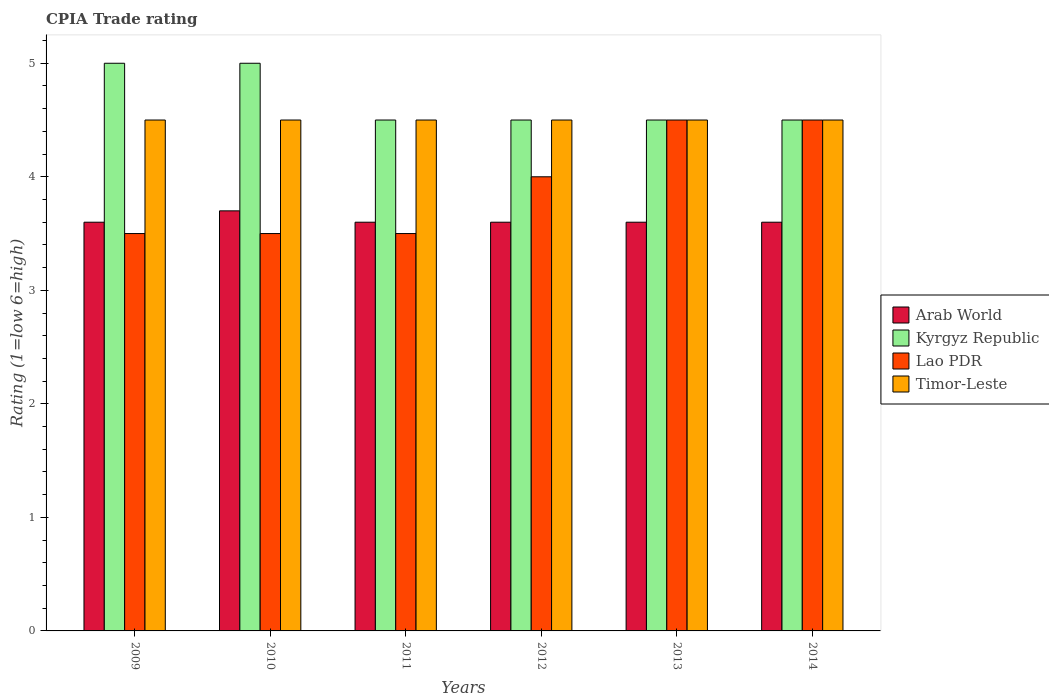How many groups of bars are there?
Ensure brevity in your answer.  6. How many bars are there on the 2nd tick from the right?
Your response must be concise. 4. What is the label of the 1st group of bars from the left?
Offer a very short reply. 2009. Across all years, what is the maximum CPIA rating in Timor-Leste?
Your response must be concise. 4.5. In which year was the CPIA rating in Kyrgyz Republic minimum?
Make the answer very short. 2011. What is the difference between the CPIA rating in Arab World in 2010 and the CPIA rating in Timor-Leste in 2013?
Your answer should be compact. -0.8. What is the average CPIA rating in Timor-Leste per year?
Make the answer very short. 4.5. In the year 2010, what is the difference between the CPIA rating in Arab World and CPIA rating in Timor-Leste?
Provide a succinct answer. -0.8. What is the ratio of the CPIA rating in Timor-Leste in 2010 to that in 2011?
Your response must be concise. 1. Is the CPIA rating in Timor-Leste in 2010 less than that in 2014?
Give a very brief answer. No. Is the difference between the CPIA rating in Arab World in 2009 and 2010 greater than the difference between the CPIA rating in Timor-Leste in 2009 and 2010?
Your response must be concise. No. What is the difference between the highest and the lowest CPIA rating in Lao PDR?
Your answer should be compact. 1. In how many years, is the CPIA rating in Arab World greater than the average CPIA rating in Arab World taken over all years?
Keep it short and to the point. 1. Is the sum of the CPIA rating in Kyrgyz Republic in 2011 and 2013 greater than the maximum CPIA rating in Lao PDR across all years?
Make the answer very short. Yes. What does the 3rd bar from the left in 2014 represents?
Make the answer very short. Lao PDR. What does the 2nd bar from the right in 2011 represents?
Give a very brief answer. Lao PDR. Is it the case that in every year, the sum of the CPIA rating in Timor-Leste and CPIA rating in Kyrgyz Republic is greater than the CPIA rating in Lao PDR?
Keep it short and to the point. Yes. Are all the bars in the graph horizontal?
Offer a terse response. No. How many years are there in the graph?
Provide a succinct answer. 6. What is the difference between two consecutive major ticks on the Y-axis?
Offer a very short reply. 1. Are the values on the major ticks of Y-axis written in scientific E-notation?
Offer a terse response. No. Does the graph contain any zero values?
Your answer should be very brief. No. How many legend labels are there?
Make the answer very short. 4. How are the legend labels stacked?
Ensure brevity in your answer.  Vertical. What is the title of the graph?
Offer a very short reply. CPIA Trade rating. What is the label or title of the X-axis?
Offer a very short reply. Years. What is the Rating (1=low 6=high) of Kyrgyz Republic in 2009?
Provide a short and direct response. 5. What is the Rating (1=low 6=high) of Arab World in 2010?
Your answer should be compact. 3.7. What is the Rating (1=low 6=high) in Timor-Leste in 2010?
Keep it short and to the point. 4.5. What is the Rating (1=low 6=high) in Arab World in 2011?
Make the answer very short. 3.6. What is the Rating (1=low 6=high) in Arab World in 2012?
Keep it short and to the point. 3.6. What is the Rating (1=low 6=high) of Lao PDR in 2012?
Your answer should be very brief. 4. What is the Rating (1=low 6=high) in Timor-Leste in 2012?
Offer a very short reply. 4.5. What is the Rating (1=low 6=high) of Kyrgyz Republic in 2013?
Keep it short and to the point. 4.5. What is the Rating (1=low 6=high) in Timor-Leste in 2013?
Provide a short and direct response. 4.5. What is the Rating (1=low 6=high) of Lao PDR in 2014?
Provide a short and direct response. 4.5. Across all years, what is the maximum Rating (1=low 6=high) of Lao PDR?
Keep it short and to the point. 4.5. Across all years, what is the maximum Rating (1=low 6=high) of Timor-Leste?
Give a very brief answer. 4.5. Across all years, what is the minimum Rating (1=low 6=high) in Arab World?
Your response must be concise. 3.6. Across all years, what is the minimum Rating (1=low 6=high) of Kyrgyz Republic?
Make the answer very short. 4.5. Across all years, what is the minimum Rating (1=low 6=high) in Lao PDR?
Offer a very short reply. 3.5. Across all years, what is the minimum Rating (1=low 6=high) in Timor-Leste?
Your answer should be compact. 4.5. What is the total Rating (1=low 6=high) of Arab World in the graph?
Make the answer very short. 21.7. What is the total Rating (1=low 6=high) of Kyrgyz Republic in the graph?
Your response must be concise. 28. What is the difference between the Rating (1=low 6=high) in Arab World in 2009 and that in 2010?
Give a very brief answer. -0.1. What is the difference between the Rating (1=low 6=high) of Kyrgyz Republic in 2009 and that in 2010?
Your answer should be very brief. 0. What is the difference between the Rating (1=low 6=high) of Timor-Leste in 2009 and that in 2010?
Make the answer very short. 0. What is the difference between the Rating (1=low 6=high) of Arab World in 2009 and that in 2011?
Make the answer very short. 0. What is the difference between the Rating (1=low 6=high) of Kyrgyz Republic in 2009 and that in 2011?
Offer a very short reply. 0.5. What is the difference between the Rating (1=low 6=high) of Timor-Leste in 2009 and that in 2011?
Provide a succinct answer. 0. What is the difference between the Rating (1=low 6=high) of Arab World in 2009 and that in 2012?
Make the answer very short. 0. What is the difference between the Rating (1=low 6=high) of Kyrgyz Republic in 2009 and that in 2014?
Provide a short and direct response. 0.5. What is the difference between the Rating (1=low 6=high) of Lao PDR in 2009 and that in 2014?
Keep it short and to the point. -1. What is the difference between the Rating (1=low 6=high) of Timor-Leste in 2009 and that in 2014?
Make the answer very short. 0. What is the difference between the Rating (1=low 6=high) of Arab World in 2010 and that in 2011?
Keep it short and to the point. 0.1. What is the difference between the Rating (1=low 6=high) in Timor-Leste in 2010 and that in 2011?
Ensure brevity in your answer.  0. What is the difference between the Rating (1=low 6=high) of Arab World in 2010 and that in 2012?
Ensure brevity in your answer.  0.1. What is the difference between the Rating (1=low 6=high) in Lao PDR in 2010 and that in 2012?
Offer a terse response. -0.5. What is the difference between the Rating (1=low 6=high) in Lao PDR in 2011 and that in 2012?
Provide a short and direct response. -0.5. What is the difference between the Rating (1=low 6=high) in Timor-Leste in 2011 and that in 2012?
Keep it short and to the point. 0. What is the difference between the Rating (1=low 6=high) in Arab World in 2011 and that in 2013?
Provide a short and direct response. 0. What is the difference between the Rating (1=low 6=high) in Lao PDR in 2011 and that in 2013?
Your answer should be very brief. -1. What is the difference between the Rating (1=low 6=high) in Timor-Leste in 2011 and that in 2013?
Provide a short and direct response. 0. What is the difference between the Rating (1=low 6=high) of Timor-Leste in 2011 and that in 2014?
Your response must be concise. 0. What is the difference between the Rating (1=low 6=high) in Arab World in 2012 and that in 2013?
Keep it short and to the point. 0. What is the difference between the Rating (1=low 6=high) in Kyrgyz Republic in 2012 and that in 2013?
Provide a short and direct response. 0. What is the difference between the Rating (1=low 6=high) in Timor-Leste in 2012 and that in 2013?
Your answer should be very brief. 0. What is the difference between the Rating (1=low 6=high) of Arab World in 2012 and that in 2014?
Offer a terse response. 0. What is the difference between the Rating (1=low 6=high) in Kyrgyz Republic in 2012 and that in 2014?
Provide a short and direct response. 0. What is the difference between the Rating (1=low 6=high) in Timor-Leste in 2012 and that in 2014?
Provide a short and direct response. 0. What is the difference between the Rating (1=low 6=high) in Arab World in 2013 and that in 2014?
Offer a terse response. 0. What is the difference between the Rating (1=low 6=high) of Timor-Leste in 2013 and that in 2014?
Provide a succinct answer. 0. What is the difference between the Rating (1=low 6=high) of Arab World in 2009 and the Rating (1=low 6=high) of Lao PDR in 2010?
Offer a very short reply. 0.1. What is the difference between the Rating (1=low 6=high) in Lao PDR in 2009 and the Rating (1=low 6=high) in Timor-Leste in 2010?
Make the answer very short. -1. What is the difference between the Rating (1=low 6=high) in Arab World in 2009 and the Rating (1=low 6=high) in Timor-Leste in 2011?
Provide a short and direct response. -0.9. What is the difference between the Rating (1=low 6=high) of Kyrgyz Republic in 2009 and the Rating (1=low 6=high) of Lao PDR in 2011?
Provide a short and direct response. 1.5. What is the difference between the Rating (1=low 6=high) in Lao PDR in 2009 and the Rating (1=low 6=high) in Timor-Leste in 2011?
Ensure brevity in your answer.  -1. What is the difference between the Rating (1=low 6=high) in Arab World in 2009 and the Rating (1=low 6=high) in Kyrgyz Republic in 2012?
Your response must be concise. -0.9. What is the difference between the Rating (1=low 6=high) of Kyrgyz Republic in 2009 and the Rating (1=low 6=high) of Lao PDR in 2012?
Make the answer very short. 1. What is the difference between the Rating (1=low 6=high) of Lao PDR in 2009 and the Rating (1=low 6=high) of Timor-Leste in 2012?
Your answer should be very brief. -1. What is the difference between the Rating (1=low 6=high) in Arab World in 2009 and the Rating (1=low 6=high) in Kyrgyz Republic in 2013?
Offer a terse response. -0.9. What is the difference between the Rating (1=low 6=high) in Arab World in 2009 and the Rating (1=low 6=high) in Lao PDR in 2013?
Keep it short and to the point. -0.9. What is the difference between the Rating (1=low 6=high) in Kyrgyz Republic in 2009 and the Rating (1=low 6=high) in Lao PDR in 2013?
Your answer should be compact. 0.5. What is the difference between the Rating (1=low 6=high) in Lao PDR in 2009 and the Rating (1=low 6=high) in Timor-Leste in 2013?
Keep it short and to the point. -1. What is the difference between the Rating (1=low 6=high) of Arab World in 2010 and the Rating (1=low 6=high) of Timor-Leste in 2011?
Provide a succinct answer. -0.8. What is the difference between the Rating (1=low 6=high) of Kyrgyz Republic in 2010 and the Rating (1=low 6=high) of Lao PDR in 2011?
Your response must be concise. 1.5. What is the difference between the Rating (1=low 6=high) in Arab World in 2010 and the Rating (1=low 6=high) in Timor-Leste in 2012?
Keep it short and to the point. -0.8. What is the difference between the Rating (1=low 6=high) in Kyrgyz Republic in 2010 and the Rating (1=low 6=high) in Timor-Leste in 2012?
Give a very brief answer. 0.5. What is the difference between the Rating (1=low 6=high) of Arab World in 2010 and the Rating (1=low 6=high) of Lao PDR in 2013?
Make the answer very short. -0.8. What is the difference between the Rating (1=low 6=high) of Kyrgyz Republic in 2010 and the Rating (1=low 6=high) of Lao PDR in 2013?
Your answer should be compact. 0.5. What is the difference between the Rating (1=low 6=high) in Arab World in 2010 and the Rating (1=low 6=high) in Kyrgyz Republic in 2014?
Your answer should be compact. -0.8. What is the difference between the Rating (1=low 6=high) in Arab World in 2010 and the Rating (1=low 6=high) in Lao PDR in 2014?
Your answer should be very brief. -0.8. What is the difference between the Rating (1=low 6=high) of Arab World in 2011 and the Rating (1=low 6=high) of Kyrgyz Republic in 2012?
Your answer should be compact. -0.9. What is the difference between the Rating (1=low 6=high) in Arab World in 2011 and the Rating (1=low 6=high) in Lao PDR in 2012?
Give a very brief answer. -0.4. What is the difference between the Rating (1=low 6=high) in Arab World in 2011 and the Rating (1=low 6=high) in Timor-Leste in 2012?
Your response must be concise. -0.9. What is the difference between the Rating (1=low 6=high) in Kyrgyz Republic in 2011 and the Rating (1=low 6=high) in Timor-Leste in 2012?
Make the answer very short. 0. What is the difference between the Rating (1=low 6=high) in Arab World in 2011 and the Rating (1=low 6=high) in Lao PDR in 2013?
Give a very brief answer. -0.9. What is the difference between the Rating (1=low 6=high) in Arab World in 2011 and the Rating (1=low 6=high) in Timor-Leste in 2013?
Make the answer very short. -0.9. What is the difference between the Rating (1=low 6=high) in Arab World in 2011 and the Rating (1=low 6=high) in Kyrgyz Republic in 2014?
Provide a short and direct response. -0.9. What is the difference between the Rating (1=low 6=high) in Kyrgyz Republic in 2011 and the Rating (1=low 6=high) in Lao PDR in 2014?
Ensure brevity in your answer.  0. What is the difference between the Rating (1=low 6=high) of Kyrgyz Republic in 2011 and the Rating (1=low 6=high) of Timor-Leste in 2014?
Your response must be concise. 0. What is the difference between the Rating (1=low 6=high) of Lao PDR in 2011 and the Rating (1=low 6=high) of Timor-Leste in 2014?
Your answer should be compact. -1. What is the difference between the Rating (1=low 6=high) of Arab World in 2012 and the Rating (1=low 6=high) of Kyrgyz Republic in 2013?
Give a very brief answer. -0.9. What is the difference between the Rating (1=low 6=high) in Arab World in 2012 and the Rating (1=low 6=high) in Lao PDR in 2013?
Ensure brevity in your answer.  -0.9. What is the difference between the Rating (1=low 6=high) of Arab World in 2012 and the Rating (1=low 6=high) of Timor-Leste in 2013?
Offer a terse response. -0.9. What is the difference between the Rating (1=low 6=high) of Arab World in 2012 and the Rating (1=low 6=high) of Lao PDR in 2014?
Offer a very short reply. -0.9. What is the difference between the Rating (1=low 6=high) in Kyrgyz Republic in 2012 and the Rating (1=low 6=high) in Lao PDR in 2014?
Provide a succinct answer. 0. What is the difference between the Rating (1=low 6=high) in Kyrgyz Republic in 2012 and the Rating (1=low 6=high) in Timor-Leste in 2014?
Give a very brief answer. 0. What is the difference between the Rating (1=low 6=high) in Arab World in 2013 and the Rating (1=low 6=high) in Lao PDR in 2014?
Give a very brief answer. -0.9. What is the difference between the Rating (1=low 6=high) in Kyrgyz Republic in 2013 and the Rating (1=low 6=high) in Lao PDR in 2014?
Keep it short and to the point. 0. What is the difference between the Rating (1=low 6=high) of Kyrgyz Republic in 2013 and the Rating (1=low 6=high) of Timor-Leste in 2014?
Provide a short and direct response. 0. What is the difference between the Rating (1=low 6=high) of Lao PDR in 2013 and the Rating (1=low 6=high) of Timor-Leste in 2014?
Ensure brevity in your answer.  0. What is the average Rating (1=low 6=high) in Arab World per year?
Provide a short and direct response. 3.62. What is the average Rating (1=low 6=high) of Kyrgyz Republic per year?
Provide a succinct answer. 4.67. What is the average Rating (1=low 6=high) in Lao PDR per year?
Your answer should be compact. 3.92. In the year 2009, what is the difference between the Rating (1=low 6=high) in Kyrgyz Republic and Rating (1=low 6=high) in Lao PDR?
Offer a terse response. 1.5. In the year 2009, what is the difference between the Rating (1=low 6=high) in Lao PDR and Rating (1=low 6=high) in Timor-Leste?
Provide a succinct answer. -1. In the year 2010, what is the difference between the Rating (1=low 6=high) in Arab World and Rating (1=low 6=high) in Kyrgyz Republic?
Ensure brevity in your answer.  -1.3. In the year 2010, what is the difference between the Rating (1=low 6=high) in Arab World and Rating (1=low 6=high) in Lao PDR?
Give a very brief answer. 0.2. In the year 2010, what is the difference between the Rating (1=low 6=high) in Kyrgyz Republic and Rating (1=low 6=high) in Lao PDR?
Offer a very short reply. 1.5. In the year 2010, what is the difference between the Rating (1=low 6=high) of Kyrgyz Republic and Rating (1=low 6=high) of Timor-Leste?
Give a very brief answer. 0.5. In the year 2011, what is the difference between the Rating (1=low 6=high) in Arab World and Rating (1=low 6=high) in Lao PDR?
Keep it short and to the point. 0.1. In the year 2011, what is the difference between the Rating (1=low 6=high) in Arab World and Rating (1=low 6=high) in Timor-Leste?
Offer a terse response. -0.9. In the year 2012, what is the difference between the Rating (1=low 6=high) of Arab World and Rating (1=low 6=high) of Kyrgyz Republic?
Offer a terse response. -0.9. In the year 2012, what is the difference between the Rating (1=low 6=high) in Arab World and Rating (1=low 6=high) in Timor-Leste?
Provide a succinct answer. -0.9. In the year 2012, what is the difference between the Rating (1=low 6=high) in Kyrgyz Republic and Rating (1=low 6=high) in Lao PDR?
Keep it short and to the point. 0.5. In the year 2012, what is the difference between the Rating (1=low 6=high) of Lao PDR and Rating (1=low 6=high) of Timor-Leste?
Your response must be concise. -0.5. In the year 2013, what is the difference between the Rating (1=low 6=high) of Arab World and Rating (1=low 6=high) of Lao PDR?
Your answer should be very brief. -0.9. In the year 2014, what is the difference between the Rating (1=low 6=high) in Arab World and Rating (1=low 6=high) in Lao PDR?
Ensure brevity in your answer.  -0.9. In the year 2014, what is the difference between the Rating (1=low 6=high) in Kyrgyz Republic and Rating (1=low 6=high) in Lao PDR?
Your answer should be compact. 0. In the year 2014, what is the difference between the Rating (1=low 6=high) of Kyrgyz Republic and Rating (1=low 6=high) of Timor-Leste?
Make the answer very short. 0. What is the ratio of the Rating (1=low 6=high) in Lao PDR in 2009 to that in 2010?
Offer a terse response. 1. What is the ratio of the Rating (1=low 6=high) in Timor-Leste in 2009 to that in 2010?
Your answer should be very brief. 1. What is the ratio of the Rating (1=low 6=high) in Arab World in 2009 to that in 2011?
Your answer should be compact. 1. What is the ratio of the Rating (1=low 6=high) in Kyrgyz Republic in 2009 to that in 2011?
Ensure brevity in your answer.  1.11. What is the ratio of the Rating (1=low 6=high) in Lao PDR in 2009 to that in 2011?
Keep it short and to the point. 1. What is the ratio of the Rating (1=low 6=high) of Arab World in 2009 to that in 2012?
Your response must be concise. 1. What is the ratio of the Rating (1=low 6=high) of Lao PDR in 2009 to that in 2012?
Keep it short and to the point. 0.88. What is the ratio of the Rating (1=low 6=high) of Timor-Leste in 2009 to that in 2012?
Give a very brief answer. 1. What is the ratio of the Rating (1=low 6=high) in Arab World in 2009 to that in 2013?
Provide a succinct answer. 1. What is the ratio of the Rating (1=low 6=high) of Kyrgyz Republic in 2009 to that in 2013?
Make the answer very short. 1.11. What is the ratio of the Rating (1=low 6=high) in Lao PDR in 2009 to that in 2013?
Your answer should be very brief. 0.78. What is the ratio of the Rating (1=low 6=high) of Arab World in 2009 to that in 2014?
Provide a succinct answer. 1. What is the ratio of the Rating (1=low 6=high) of Arab World in 2010 to that in 2011?
Make the answer very short. 1.03. What is the ratio of the Rating (1=low 6=high) of Lao PDR in 2010 to that in 2011?
Give a very brief answer. 1. What is the ratio of the Rating (1=low 6=high) of Arab World in 2010 to that in 2012?
Make the answer very short. 1.03. What is the ratio of the Rating (1=low 6=high) in Kyrgyz Republic in 2010 to that in 2012?
Your answer should be very brief. 1.11. What is the ratio of the Rating (1=low 6=high) in Arab World in 2010 to that in 2013?
Give a very brief answer. 1.03. What is the ratio of the Rating (1=low 6=high) of Timor-Leste in 2010 to that in 2013?
Offer a very short reply. 1. What is the ratio of the Rating (1=low 6=high) in Arab World in 2010 to that in 2014?
Offer a very short reply. 1.03. What is the ratio of the Rating (1=low 6=high) of Lao PDR in 2010 to that in 2014?
Your answer should be compact. 0.78. What is the ratio of the Rating (1=low 6=high) of Kyrgyz Republic in 2011 to that in 2012?
Ensure brevity in your answer.  1. What is the ratio of the Rating (1=low 6=high) of Timor-Leste in 2011 to that in 2012?
Make the answer very short. 1. What is the ratio of the Rating (1=low 6=high) of Arab World in 2011 to that in 2013?
Offer a terse response. 1. What is the ratio of the Rating (1=low 6=high) in Arab World in 2011 to that in 2014?
Ensure brevity in your answer.  1. What is the ratio of the Rating (1=low 6=high) in Lao PDR in 2011 to that in 2014?
Your answer should be very brief. 0.78. What is the ratio of the Rating (1=low 6=high) of Timor-Leste in 2011 to that in 2014?
Your answer should be very brief. 1. What is the ratio of the Rating (1=low 6=high) in Kyrgyz Republic in 2012 to that in 2013?
Provide a short and direct response. 1. What is the ratio of the Rating (1=low 6=high) in Lao PDR in 2012 to that in 2013?
Ensure brevity in your answer.  0.89. What is the ratio of the Rating (1=low 6=high) in Timor-Leste in 2012 to that in 2013?
Keep it short and to the point. 1. What is the ratio of the Rating (1=low 6=high) in Kyrgyz Republic in 2012 to that in 2014?
Give a very brief answer. 1. What is the ratio of the Rating (1=low 6=high) in Timor-Leste in 2012 to that in 2014?
Provide a short and direct response. 1. What is the ratio of the Rating (1=low 6=high) of Arab World in 2013 to that in 2014?
Provide a short and direct response. 1. What is the ratio of the Rating (1=low 6=high) of Kyrgyz Republic in 2013 to that in 2014?
Offer a terse response. 1. What is the ratio of the Rating (1=low 6=high) in Lao PDR in 2013 to that in 2014?
Make the answer very short. 1. What is the difference between the highest and the second highest Rating (1=low 6=high) in Arab World?
Make the answer very short. 0.1. What is the difference between the highest and the second highest Rating (1=low 6=high) in Timor-Leste?
Your answer should be compact. 0. What is the difference between the highest and the lowest Rating (1=low 6=high) of Timor-Leste?
Your answer should be very brief. 0. 